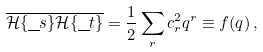<formula> <loc_0><loc_0><loc_500><loc_500>\overline { \mathcal { H } \{ \underline { \ } s \} \mathcal { H } \{ \underline { \ } t \} } = \frac { 1 } { 2 } \sum _ { r } c _ { r } ^ { 2 } q ^ { r } \equiv f ( q ) \, ,</formula> 